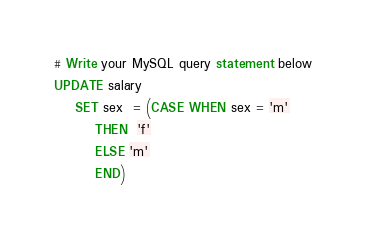<code> <loc_0><loc_0><loc_500><loc_500><_SQL_># Write your MySQL query statement below
UPDATE salary
    SET sex  = (CASE WHEN sex = 'm'
        THEN  'f'
        ELSE 'm'
        END)</code> 